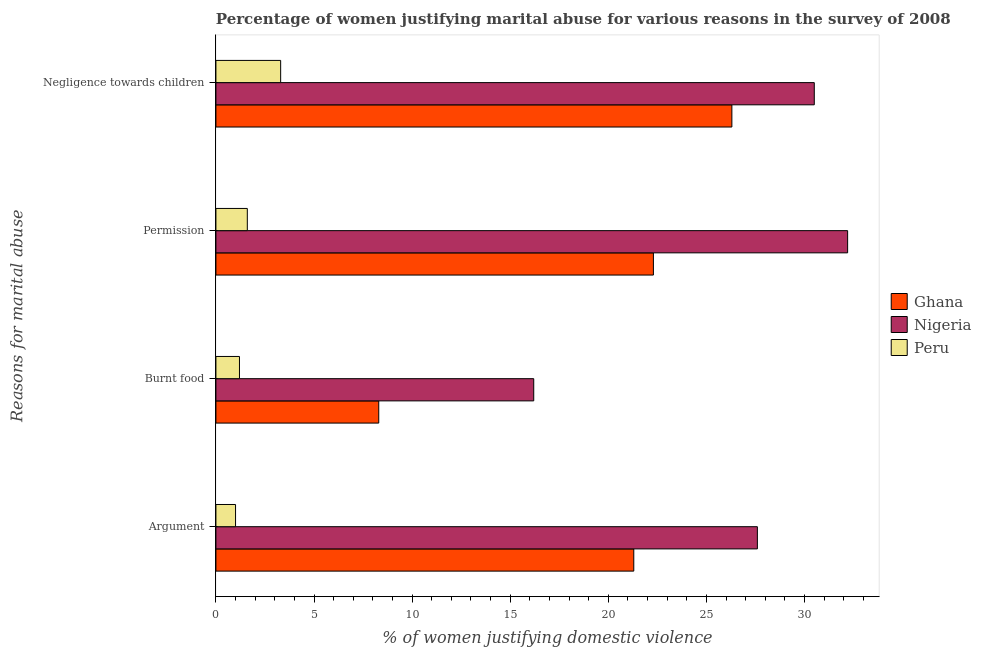Are the number of bars per tick equal to the number of legend labels?
Make the answer very short. Yes. How many bars are there on the 2nd tick from the top?
Ensure brevity in your answer.  3. How many bars are there on the 2nd tick from the bottom?
Make the answer very short. 3. What is the label of the 4th group of bars from the top?
Offer a terse response. Argument. What is the percentage of women justifying abuse for going without permission in Ghana?
Offer a terse response. 22.3. Across all countries, what is the minimum percentage of women justifying abuse for showing negligence towards children?
Give a very brief answer. 3.3. In which country was the percentage of women justifying abuse in the case of an argument maximum?
Give a very brief answer. Nigeria. In which country was the percentage of women justifying abuse for burning food minimum?
Your answer should be compact. Peru. What is the total percentage of women justifying abuse for showing negligence towards children in the graph?
Provide a succinct answer. 60.1. What is the difference between the percentage of women justifying abuse for going without permission in Peru and that in Nigeria?
Make the answer very short. -30.6. What is the difference between the percentage of women justifying abuse for burning food in Nigeria and the percentage of women justifying abuse for showing negligence towards children in Ghana?
Make the answer very short. -10.1. What is the average percentage of women justifying abuse for going without permission per country?
Your answer should be compact. 18.7. What is the difference between the percentage of women justifying abuse for going without permission and percentage of women justifying abuse for showing negligence towards children in Nigeria?
Your response must be concise. 1.7. In how many countries, is the percentage of women justifying abuse for showing negligence towards children greater than 32 %?
Keep it short and to the point. 0. What is the ratio of the percentage of women justifying abuse for going without permission in Peru to that in Ghana?
Make the answer very short. 0.07. What is the difference between the highest and the second highest percentage of women justifying abuse in the case of an argument?
Provide a short and direct response. 6.3. What is the difference between the highest and the lowest percentage of women justifying abuse for burning food?
Offer a very short reply. 15. In how many countries, is the percentage of women justifying abuse for burning food greater than the average percentage of women justifying abuse for burning food taken over all countries?
Make the answer very short. 1. What does the 1st bar from the top in Burnt food represents?
Give a very brief answer. Peru. What does the 2nd bar from the bottom in Negligence towards children represents?
Make the answer very short. Nigeria. How many bars are there?
Offer a very short reply. 12. Are the values on the major ticks of X-axis written in scientific E-notation?
Offer a terse response. No. Does the graph contain any zero values?
Your answer should be compact. No. Where does the legend appear in the graph?
Provide a succinct answer. Center right. What is the title of the graph?
Provide a short and direct response. Percentage of women justifying marital abuse for various reasons in the survey of 2008. Does "Korea (Republic)" appear as one of the legend labels in the graph?
Provide a short and direct response. No. What is the label or title of the X-axis?
Make the answer very short. % of women justifying domestic violence. What is the label or title of the Y-axis?
Offer a very short reply. Reasons for marital abuse. What is the % of women justifying domestic violence of Ghana in Argument?
Offer a terse response. 21.3. What is the % of women justifying domestic violence of Nigeria in Argument?
Provide a short and direct response. 27.6. What is the % of women justifying domestic violence of Nigeria in Burnt food?
Your answer should be very brief. 16.2. What is the % of women justifying domestic violence in Peru in Burnt food?
Offer a very short reply. 1.2. What is the % of women justifying domestic violence of Ghana in Permission?
Offer a very short reply. 22.3. What is the % of women justifying domestic violence in Nigeria in Permission?
Offer a very short reply. 32.2. What is the % of women justifying domestic violence in Peru in Permission?
Offer a terse response. 1.6. What is the % of women justifying domestic violence of Ghana in Negligence towards children?
Your response must be concise. 26.3. What is the % of women justifying domestic violence in Nigeria in Negligence towards children?
Offer a terse response. 30.5. Across all Reasons for marital abuse, what is the maximum % of women justifying domestic violence in Ghana?
Offer a terse response. 26.3. Across all Reasons for marital abuse, what is the maximum % of women justifying domestic violence of Nigeria?
Provide a succinct answer. 32.2. Across all Reasons for marital abuse, what is the minimum % of women justifying domestic violence in Ghana?
Ensure brevity in your answer.  8.3. Across all Reasons for marital abuse, what is the minimum % of women justifying domestic violence of Nigeria?
Your answer should be very brief. 16.2. Across all Reasons for marital abuse, what is the minimum % of women justifying domestic violence in Peru?
Make the answer very short. 1. What is the total % of women justifying domestic violence in Ghana in the graph?
Your response must be concise. 78.2. What is the total % of women justifying domestic violence of Nigeria in the graph?
Offer a very short reply. 106.5. What is the difference between the % of women justifying domestic violence in Ghana in Argument and that in Burnt food?
Your answer should be very brief. 13. What is the difference between the % of women justifying domestic violence of Peru in Argument and that in Burnt food?
Make the answer very short. -0.2. What is the difference between the % of women justifying domestic violence in Ghana in Argument and that in Permission?
Your response must be concise. -1. What is the difference between the % of women justifying domestic violence of Nigeria in Argument and that in Permission?
Offer a terse response. -4.6. What is the difference between the % of women justifying domestic violence in Peru in Argument and that in Permission?
Provide a short and direct response. -0.6. What is the difference between the % of women justifying domestic violence of Ghana in Argument and that in Negligence towards children?
Your answer should be very brief. -5. What is the difference between the % of women justifying domestic violence in Peru in Argument and that in Negligence towards children?
Provide a short and direct response. -2.3. What is the difference between the % of women justifying domestic violence in Ghana in Burnt food and that in Permission?
Offer a very short reply. -14. What is the difference between the % of women justifying domestic violence in Nigeria in Burnt food and that in Negligence towards children?
Provide a short and direct response. -14.3. What is the difference between the % of women justifying domestic violence in Peru in Burnt food and that in Negligence towards children?
Make the answer very short. -2.1. What is the difference between the % of women justifying domestic violence of Ghana in Permission and that in Negligence towards children?
Make the answer very short. -4. What is the difference between the % of women justifying domestic violence of Nigeria in Permission and that in Negligence towards children?
Make the answer very short. 1.7. What is the difference between the % of women justifying domestic violence in Peru in Permission and that in Negligence towards children?
Provide a succinct answer. -1.7. What is the difference between the % of women justifying domestic violence in Ghana in Argument and the % of women justifying domestic violence in Nigeria in Burnt food?
Your answer should be very brief. 5.1. What is the difference between the % of women justifying domestic violence in Ghana in Argument and the % of women justifying domestic violence in Peru in Burnt food?
Keep it short and to the point. 20.1. What is the difference between the % of women justifying domestic violence of Nigeria in Argument and the % of women justifying domestic violence of Peru in Burnt food?
Offer a terse response. 26.4. What is the difference between the % of women justifying domestic violence of Ghana in Argument and the % of women justifying domestic violence of Peru in Permission?
Provide a short and direct response. 19.7. What is the difference between the % of women justifying domestic violence of Ghana in Argument and the % of women justifying domestic violence of Peru in Negligence towards children?
Provide a succinct answer. 18. What is the difference between the % of women justifying domestic violence of Nigeria in Argument and the % of women justifying domestic violence of Peru in Negligence towards children?
Your answer should be compact. 24.3. What is the difference between the % of women justifying domestic violence in Ghana in Burnt food and the % of women justifying domestic violence in Nigeria in Permission?
Offer a very short reply. -23.9. What is the difference between the % of women justifying domestic violence of Ghana in Burnt food and the % of women justifying domestic violence of Peru in Permission?
Keep it short and to the point. 6.7. What is the difference between the % of women justifying domestic violence of Ghana in Burnt food and the % of women justifying domestic violence of Nigeria in Negligence towards children?
Your response must be concise. -22.2. What is the difference between the % of women justifying domestic violence of Ghana in Burnt food and the % of women justifying domestic violence of Peru in Negligence towards children?
Offer a terse response. 5. What is the difference between the % of women justifying domestic violence in Nigeria in Burnt food and the % of women justifying domestic violence in Peru in Negligence towards children?
Provide a succinct answer. 12.9. What is the difference between the % of women justifying domestic violence in Ghana in Permission and the % of women justifying domestic violence in Nigeria in Negligence towards children?
Provide a short and direct response. -8.2. What is the difference between the % of women justifying domestic violence of Nigeria in Permission and the % of women justifying domestic violence of Peru in Negligence towards children?
Offer a terse response. 28.9. What is the average % of women justifying domestic violence of Ghana per Reasons for marital abuse?
Offer a terse response. 19.55. What is the average % of women justifying domestic violence in Nigeria per Reasons for marital abuse?
Give a very brief answer. 26.62. What is the average % of women justifying domestic violence of Peru per Reasons for marital abuse?
Give a very brief answer. 1.77. What is the difference between the % of women justifying domestic violence of Ghana and % of women justifying domestic violence of Nigeria in Argument?
Offer a terse response. -6.3. What is the difference between the % of women justifying domestic violence of Ghana and % of women justifying domestic violence of Peru in Argument?
Your answer should be very brief. 20.3. What is the difference between the % of women justifying domestic violence of Nigeria and % of women justifying domestic violence of Peru in Argument?
Provide a short and direct response. 26.6. What is the difference between the % of women justifying domestic violence of Ghana and % of women justifying domestic violence of Nigeria in Burnt food?
Your answer should be compact. -7.9. What is the difference between the % of women justifying domestic violence in Nigeria and % of women justifying domestic violence in Peru in Burnt food?
Provide a short and direct response. 15. What is the difference between the % of women justifying domestic violence in Ghana and % of women justifying domestic violence in Peru in Permission?
Provide a succinct answer. 20.7. What is the difference between the % of women justifying domestic violence of Nigeria and % of women justifying domestic violence of Peru in Permission?
Provide a succinct answer. 30.6. What is the difference between the % of women justifying domestic violence in Ghana and % of women justifying domestic violence in Nigeria in Negligence towards children?
Provide a succinct answer. -4.2. What is the difference between the % of women justifying domestic violence of Ghana and % of women justifying domestic violence of Peru in Negligence towards children?
Make the answer very short. 23. What is the difference between the % of women justifying domestic violence of Nigeria and % of women justifying domestic violence of Peru in Negligence towards children?
Make the answer very short. 27.2. What is the ratio of the % of women justifying domestic violence of Ghana in Argument to that in Burnt food?
Offer a terse response. 2.57. What is the ratio of the % of women justifying domestic violence of Nigeria in Argument to that in Burnt food?
Provide a short and direct response. 1.7. What is the ratio of the % of women justifying domestic violence of Ghana in Argument to that in Permission?
Ensure brevity in your answer.  0.96. What is the ratio of the % of women justifying domestic violence in Nigeria in Argument to that in Permission?
Your answer should be compact. 0.86. What is the ratio of the % of women justifying domestic violence of Peru in Argument to that in Permission?
Make the answer very short. 0.62. What is the ratio of the % of women justifying domestic violence in Ghana in Argument to that in Negligence towards children?
Give a very brief answer. 0.81. What is the ratio of the % of women justifying domestic violence in Nigeria in Argument to that in Negligence towards children?
Provide a short and direct response. 0.9. What is the ratio of the % of women justifying domestic violence of Peru in Argument to that in Negligence towards children?
Your answer should be very brief. 0.3. What is the ratio of the % of women justifying domestic violence in Ghana in Burnt food to that in Permission?
Your response must be concise. 0.37. What is the ratio of the % of women justifying domestic violence in Nigeria in Burnt food to that in Permission?
Your answer should be very brief. 0.5. What is the ratio of the % of women justifying domestic violence in Peru in Burnt food to that in Permission?
Offer a very short reply. 0.75. What is the ratio of the % of women justifying domestic violence in Ghana in Burnt food to that in Negligence towards children?
Keep it short and to the point. 0.32. What is the ratio of the % of women justifying domestic violence in Nigeria in Burnt food to that in Negligence towards children?
Give a very brief answer. 0.53. What is the ratio of the % of women justifying domestic violence in Peru in Burnt food to that in Negligence towards children?
Keep it short and to the point. 0.36. What is the ratio of the % of women justifying domestic violence of Ghana in Permission to that in Negligence towards children?
Offer a terse response. 0.85. What is the ratio of the % of women justifying domestic violence of Nigeria in Permission to that in Negligence towards children?
Your answer should be very brief. 1.06. What is the ratio of the % of women justifying domestic violence in Peru in Permission to that in Negligence towards children?
Make the answer very short. 0.48. What is the difference between the highest and the second highest % of women justifying domestic violence of Ghana?
Ensure brevity in your answer.  4. What is the difference between the highest and the second highest % of women justifying domestic violence in Peru?
Ensure brevity in your answer.  1.7. What is the difference between the highest and the lowest % of women justifying domestic violence of Peru?
Provide a short and direct response. 2.3. 